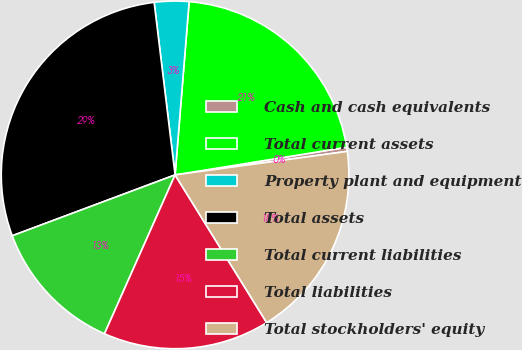Convert chart. <chart><loc_0><loc_0><loc_500><loc_500><pie_chart><fcel>Cash and cash equivalents<fcel>Total current assets<fcel>Property plant and equipment<fcel>Total assets<fcel>Total current liabilities<fcel>Total liabilities<fcel>Total stockholders' equity<nl><fcel>0.38%<fcel>21.17%<fcel>3.21%<fcel>28.77%<fcel>12.65%<fcel>15.49%<fcel>18.33%<nl></chart> 